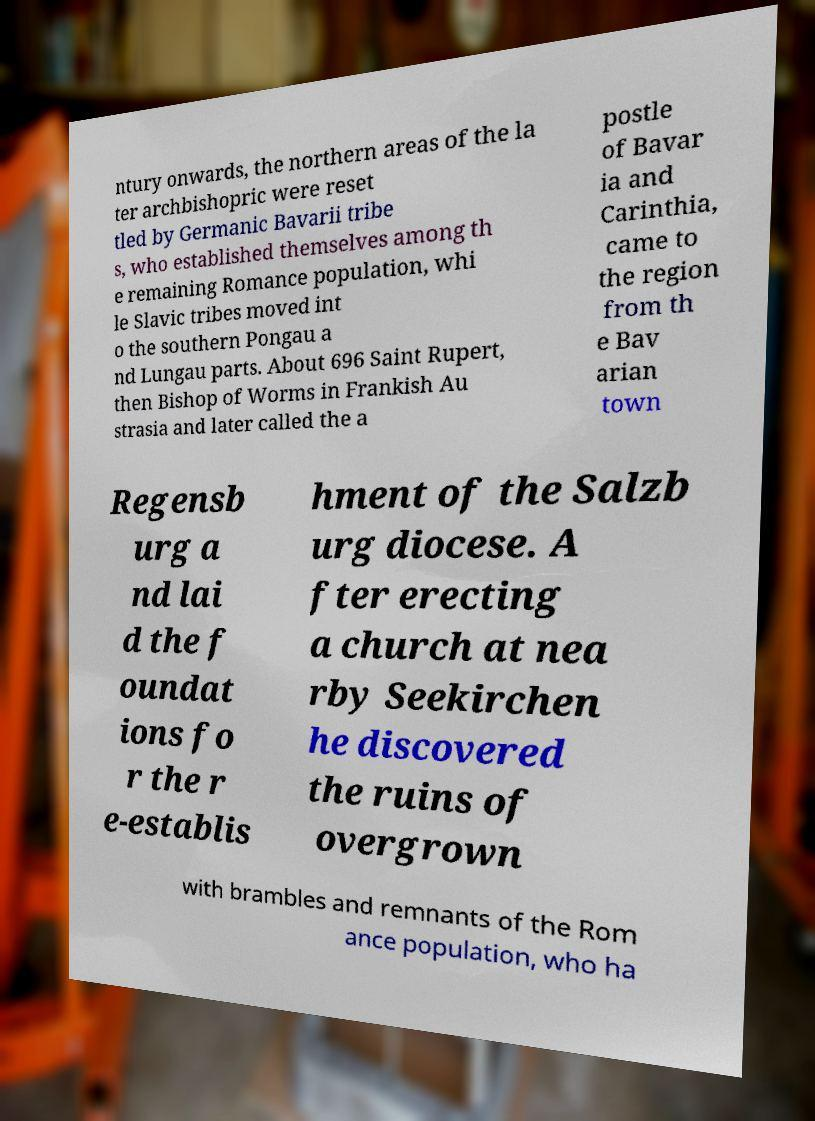I need the written content from this picture converted into text. Can you do that? ntury onwards, the northern areas of the la ter archbishopric were reset tled by Germanic Bavarii tribe s, who established themselves among th e remaining Romance population, whi le Slavic tribes moved int o the southern Pongau a nd Lungau parts. About 696 Saint Rupert, then Bishop of Worms in Frankish Au strasia and later called the a postle of Bavar ia and Carinthia, came to the region from th e Bav arian town Regensb urg a nd lai d the f oundat ions fo r the r e-establis hment of the Salzb urg diocese. A fter erecting a church at nea rby Seekirchen he discovered the ruins of overgrown with brambles and remnants of the Rom ance population, who ha 